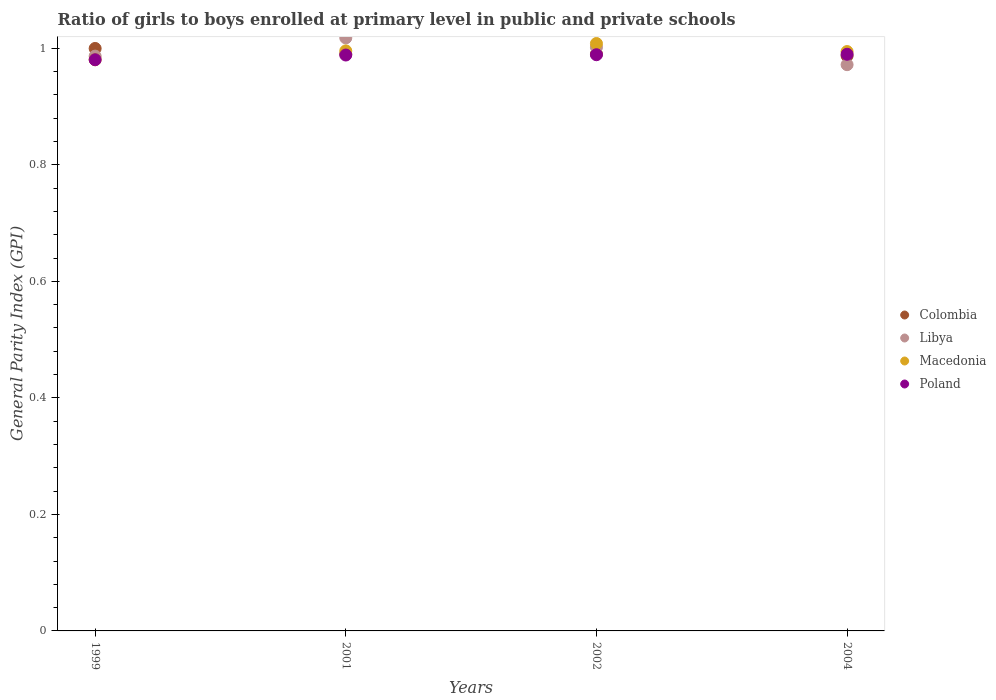What is the general parity index in Macedonia in 1999?
Ensure brevity in your answer.  0.98. Across all years, what is the maximum general parity index in Colombia?
Give a very brief answer. 1. Across all years, what is the minimum general parity index in Macedonia?
Offer a very short reply. 0.98. What is the total general parity index in Macedonia in the graph?
Keep it short and to the point. 3.98. What is the difference between the general parity index in Macedonia in 1999 and that in 2004?
Provide a succinct answer. -0.01. What is the difference between the general parity index in Libya in 1999 and the general parity index in Poland in 2001?
Your answer should be compact. -0. What is the average general parity index in Colombia per year?
Your answer should be compact. 0.99. In the year 1999, what is the difference between the general parity index in Macedonia and general parity index in Colombia?
Your response must be concise. -0.02. What is the ratio of the general parity index in Poland in 1999 to that in 2001?
Keep it short and to the point. 0.99. Is the general parity index in Colombia in 1999 less than that in 2002?
Give a very brief answer. No. Is the difference between the general parity index in Macedonia in 1999 and 2002 greater than the difference between the general parity index in Colombia in 1999 and 2002?
Provide a short and direct response. No. What is the difference between the highest and the second highest general parity index in Macedonia?
Your answer should be very brief. 0.01. What is the difference between the highest and the lowest general parity index in Poland?
Offer a terse response. 0.01. In how many years, is the general parity index in Libya greater than the average general parity index in Libya taken over all years?
Give a very brief answer. 2. Is it the case that in every year, the sum of the general parity index in Libya and general parity index in Colombia  is greater than the sum of general parity index in Macedonia and general parity index in Poland?
Provide a short and direct response. No. Is the general parity index in Poland strictly greater than the general parity index in Colombia over the years?
Give a very brief answer. No. How many years are there in the graph?
Your answer should be very brief. 4. Does the graph contain any zero values?
Offer a very short reply. No. Does the graph contain grids?
Offer a terse response. No. What is the title of the graph?
Your answer should be very brief. Ratio of girls to boys enrolled at primary level in public and private schools. Does "Europe(all income levels)" appear as one of the legend labels in the graph?
Provide a short and direct response. No. What is the label or title of the Y-axis?
Keep it short and to the point. General Parity Index (GPI). What is the General Parity Index (GPI) in Colombia in 1999?
Your answer should be very brief. 1. What is the General Parity Index (GPI) of Libya in 1999?
Provide a short and direct response. 0.99. What is the General Parity Index (GPI) of Macedonia in 1999?
Provide a short and direct response. 0.98. What is the General Parity Index (GPI) of Poland in 1999?
Provide a short and direct response. 0.98. What is the General Parity Index (GPI) of Colombia in 2001?
Your answer should be compact. 0.99. What is the General Parity Index (GPI) of Libya in 2001?
Keep it short and to the point. 1.02. What is the General Parity Index (GPI) of Macedonia in 2001?
Offer a very short reply. 1. What is the General Parity Index (GPI) of Poland in 2001?
Offer a very short reply. 0.99. What is the General Parity Index (GPI) in Colombia in 2002?
Ensure brevity in your answer.  0.99. What is the General Parity Index (GPI) in Libya in 2002?
Provide a succinct answer. 1. What is the General Parity Index (GPI) in Macedonia in 2002?
Offer a terse response. 1.01. What is the General Parity Index (GPI) in Poland in 2002?
Make the answer very short. 0.99. What is the General Parity Index (GPI) of Colombia in 2004?
Ensure brevity in your answer.  0.99. What is the General Parity Index (GPI) of Libya in 2004?
Your answer should be compact. 0.97. What is the General Parity Index (GPI) in Macedonia in 2004?
Give a very brief answer. 0.99. What is the General Parity Index (GPI) in Poland in 2004?
Your answer should be compact. 0.99. Across all years, what is the maximum General Parity Index (GPI) of Colombia?
Your answer should be very brief. 1. Across all years, what is the maximum General Parity Index (GPI) in Libya?
Provide a short and direct response. 1.02. Across all years, what is the maximum General Parity Index (GPI) in Macedonia?
Provide a succinct answer. 1.01. Across all years, what is the maximum General Parity Index (GPI) in Poland?
Make the answer very short. 0.99. Across all years, what is the minimum General Parity Index (GPI) of Colombia?
Make the answer very short. 0.99. Across all years, what is the minimum General Parity Index (GPI) of Libya?
Ensure brevity in your answer.  0.97. Across all years, what is the minimum General Parity Index (GPI) of Macedonia?
Your response must be concise. 0.98. Across all years, what is the minimum General Parity Index (GPI) of Poland?
Offer a very short reply. 0.98. What is the total General Parity Index (GPI) of Colombia in the graph?
Give a very brief answer. 3.97. What is the total General Parity Index (GPI) of Libya in the graph?
Provide a short and direct response. 3.98. What is the total General Parity Index (GPI) in Macedonia in the graph?
Your answer should be very brief. 3.98. What is the total General Parity Index (GPI) of Poland in the graph?
Offer a terse response. 3.95. What is the difference between the General Parity Index (GPI) of Colombia in 1999 and that in 2001?
Ensure brevity in your answer.  0.01. What is the difference between the General Parity Index (GPI) in Libya in 1999 and that in 2001?
Offer a terse response. -0.03. What is the difference between the General Parity Index (GPI) of Macedonia in 1999 and that in 2001?
Offer a terse response. -0.02. What is the difference between the General Parity Index (GPI) in Poland in 1999 and that in 2001?
Your response must be concise. -0.01. What is the difference between the General Parity Index (GPI) of Colombia in 1999 and that in 2002?
Your answer should be compact. 0.01. What is the difference between the General Parity Index (GPI) in Libya in 1999 and that in 2002?
Provide a succinct answer. -0.02. What is the difference between the General Parity Index (GPI) in Macedonia in 1999 and that in 2002?
Provide a succinct answer. -0.03. What is the difference between the General Parity Index (GPI) of Poland in 1999 and that in 2002?
Your response must be concise. -0.01. What is the difference between the General Parity Index (GPI) of Colombia in 1999 and that in 2004?
Provide a succinct answer. 0.01. What is the difference between the General Parity Index (GPI) in Libya in 1999 and that in 2004?
Offer a very short reply. 0.01. What is the difference between the General Parity Index (GPI) in Macedonia in 1999 and that in 2004?
Give a very brief answer. -0.01. What is the difference between the General Parity Index (GPI) of Poland in 1999 and that in 2004?
Your answer should be very brief. -0.01. What is the difference between the General Parity Index (GPI) of Colombia in 2001 and that in 2002?
Provide a short and direct response. -0. What is the difference between the General Parity Index (GPI) of Libya in 2001 and that in 2002?
Ensure brevity in your answer.  0.02. What is the difference between the General Parity Index (GPI) of Macedonia in 2001 and that in 2002?
Your answer should be compact. -0.01. What is the difference between the General Parity Index (GPI) in Poland in 2001 and that in 2002?
Keep it short and to the point. -0. What is the difference between the General Parity Index (GPI) of Colombia in 2001 and that in 2004?
Give a very brief answer. 0. What is the difference between the General Parity Index (GPI) in Libya in 2001 and that in 2004?
Keep it short and to the point. 0.05. What is the difference between the General Parity Index (GPI) in Macedonia in 2001 and that in 2004?
Make the answer very short. 0. What is the difference between the General Parity Index (GPI) in Poland in 2001 and that in 2004?
Provide a succinct answer. -0. What is the difference between the General Parity Index (GPI) of Colombia in 2002 and that in 2004?
Provide a short and direct response. 0. What is the difference between the General Parity Index (GPI) in Libya in 2002 and that in 2004?
Provide a succinct answer. 0.03. What is the difference between the General Parity Index (GPI) in Macedonia in 2002 and that in 2004?
Make the answer very short. 0.01. What is the difference between the General Parity Index (GPI) in Poland in 2002 and that in 2004?
Your response must be concise. -0. What is the difference between the General Parity Index (GPI) of Colombia in 1999 and the General Parity Index (GPI) of Libya in 2001?
Offer a terse response. -0.02. What is the difference between the General Parity Index (GPI) of Colombia in 1999 and the General Parity Index (GPI) of Macedonia in 2001?
Keep it short and to the point. 0. What is the difference between the General Parity Index (GPI) of Colombia in 1999 and the General Parity Index (GPI) of Poland in 2001?
Your response must be concise. 0.01. What is the difference between the General Parity Index (GPI) in Libya in 1999 and the General Parity Index (GPI) in Macedonia in 2001?
Your response must be concise. -0.01. What is the difference between the General Parity Index (GPI) of Libya in 1999 and the General Parity Index (GPI) of Poland in 2001?
Give a very brief answer. -0. What is the difference between the General Parity Index (GPI) of Macedonia in 1999 and the General Parity Index (GPI) of Poland in 2001?
Offer a very short reply. -0.01. What is the difference between the General Parity Index (GPI) of Colombia in 1999 and the General Parity Index (GPI) of Libya in 2002?
Offer a terse response. -0. What is the difference between the General Parity Index (GPI) of Colombia in 1999 and the General Parity Index (GPI) of Macedonia in 2002?
Give a very brief answer. -0.01. What is the difference between the General Parity Index (GPI) in Colombia in 1999 and the General Parity Index (GPI) in Poland in 2002?
Your answer should be very brief. 0.01. What is the difference between the General Parity Index (GPI) in Libya in 1999 and the General Parity Index (GPI) in Macedonia in 2002?
Your answer should be very brief. -0.02. What is the difference between the General Parity Index (GPI) of Libya in 1999 and the General Parity Index (GPI) of Poland in 2002?
Provide a succinct answer. -0. What is the difference between the General Parity Index (GPI) in Macedonia in 1999 and the General Parity Index (GPI) in Poland in 2002?
Your response must be concise. -0.01. What is the difference between the General Parity Index (GPI) in Colombia in 1999 and the General Parity Index (GPI) in Libya in 2004?
Ensure brevity in your answer.  0.03. What is the difference between the General Parity Index (GPI) in Colombia in 1999 and the General Parity Index (GPI) in Macedonia in 2004?
Your answer should be compact. 0.01. What is the difference between the General Parity Index (GPI) of Colombia in 1999 and the General Parity Index (GPI) of Poland in 2004?
Provide a short and direct response. 0.01. What is the difference between the General Parity Index (GPI) in Libya in 1999 and the General Parity Index (GPI) in Macedonia in 2004?
Offer a terse response. -0.01. What is the difference between the General Parity Index (GPI) of Libya in 1999 and the General Parity Index (GPI) of Poland in 2004?
Offer a terse response. -0. What is the difference between the General Parity Index (GPI) in Macedonia in 1999 and the General Parity Index (GPI) in Poland in 2004?
Offer a terse response. -0.01. What is the difference between the General Parity Index (GPI) of Colombia in 2001 and the General Parity Index (GPI) of Libya in 2002?
Make the answer very short. -0.01. What is the difference between the General Parity Index (GPI) of Colombia in 2001 and the General Parity Index (GPI) of Macedonia in 2002?
Provide a succinct answer. -0.02. What is the difference between the General Parity Index (GPI) in Colombia in 2001 and the General Parity Index (GPI) in Poland in 2002?
Ensure brevity in your answer.  0. What is the difference between the General Parity Index (GPI) of Libya in 2001 and the General Parity Index (GPI) of Macedonia in 2002?
Provide a succinct answer. 0.01. What is the difference between the General Parity Index (GPI) in Libya in 2001 and the General Parity Index (GPI) in Poland in 2002?
Offer a very short reply. 0.03. What is the difference between the General Parity Index (GPI) of Macedonia in 2001 and the General Parity Index (GPI) of Poland in 2002?
Offer a terse response. 0.01. What is the difference between the General Parity Index (GPI) of Colombia in 2001 and the General Parity Index (GPI) of Libya in 2004?
Offer a terse response. 0.02. What is the difference between the General Parity Index (GPI) of Colombia in 2001 and the General Parity Index (GPI) of Macedonia in 2004?
Provide a succinct answer. -0. What is the difference between the General Parity Index (GPI) of Colombia in 2001 and the General Parity Index (GPI) of Poland in 2004?
Your response must be concise. 0. What is the difference between the General Parity Index (GPI) in Libya in 2001 and the General Parity Index (GPI) in Macedonia in 2004?
Offer a very short reply. 0.02. What is the difference between the General Parity Index (GPI) of Libya in 2001 and the General Parity Index (GPI) of Poland in 2004?
Ensure brevity in your answer.  0.03. What is the difference between the General Parity Index (GPI) of Macedonia in 2001 and the General Parity Index (GPI) of Poland in 2004?
Make the answer very short. 0.01. What is the difference between the General Parity Index (GPI) in Colombia in 2002 and the General Parity Index (GPI) in Libya in 2004?
Your answer should be compact. 0.02. What is the difference between the General Parity Index (GPI) of Colombia in 2002 and the General Parity Index (GPI) of Macedonia in 2004?
Your response must be concise. -0. What is the difference between the General Parity Index (GPI) of Colombia in 2002 and the General Parity Index (GPI) of Poland in 2004?
Ensure brevity in your answer.  0. What is the difference between the General Parity Index (GPI) in Libya in 2002 and the General Parity Index (GPI) in Macedonia in 2004?
Give a very brief answer. 0.01. What is the difference between the General Parity Index (GPI) of Libya in 2002 and the General Parity Index (GPI) of Poland in 2004?
Your answer should be compact. 0.01. What is the difference between the General Parity Index (GPI) in Macedonia in 2002 and the General Parity Index (GPI) in Poland in 2004?
Keep it short and to the point. 0.02. What is the average General Parity Index (GPI) in Colombia per year?
Make the answer very short. 0.99. What is the average General Parity Index (GPI) in Poland per year?
Your answer should be compact. 0.99. In the year 1999, what is the difference between the General Parity Index (GPI) in Colombia and General Parity Index (GPI) in Libya?
Offer a terse response. 0.01. In the year 1999, what is the difference between the General Parity Index (GPI) of Colombia and General Parity Index (GPI) of Macedonia?
Ensure brevity in your answer.  0.02. In the year 1999, what is the difference between the General Parity Index (GPI) of Colombia and General Parity Index (GPI) of Poland?
Your response must be concise. 0.02. In the year 1999, what is the difference between the General Parity Index (GPI) in Libya and General Parity Index (GPI) in Macedonia?
Keep it short and to the point. 0.01. In the year 1999, what is the difference between the General Parity Index (GPI) in Libya and General Parity Index (GPI) in Poland?
Offer a terse response. 0.01. In the year 1999, what is the difference between the General Parity Index (GPI) in Macedonia and General Parity Index (GPI) in Poland?
Offer a very short reply. -0. In the year 2001, what is the difference between the General Parity Index (GPI) in Colombia and General Parity Index (GPI) in Libya?
Offer a terse response. -0.03. In the year 2001, what is the difference between the General Parity Index (GPI) of Colombia and General Parity Index (GPI) of Macedonia?
Offer a very short reply. -0.01. In the year 2001, what is the difference between the General Parity Index (GPI) of Colombia and General Parity Index (GPI) of Poland?
Your response must be concise. 0. In the year 2001, what is the difference between the General Parity Index (GPI) of Libya and General Parity Index (GPI) of Macedonia?
Make the answer very short. 0.02. In the year 2001, what is the difference between the General Parity Index (GPI) in Libya and General Parity Index (GPI) in Poland?
Your answer should be very brief. 0.03. In the year 2001, what is the difference between the General Parity Index (GPI) of Macedonia and General Parity Index (GPI) of Poland?
Your response must be concise. 0.01. In the year 2002, what is the difference between the General Parity Index (GPI) of Colombia and General Parity Index (GPI) of Libya?
Offer a very short reply. -0.01. In the year 2002, what is the difference between the General Parity Index (GPI) of Colombia and General Parity Index (GPI) of Macedonia?
Your response must be concise. -0.02. In the year 2002, what is the difference between the General Parity Index (GPI) in Colombia and General Parity Index (GPI) in Poland?
Provide a succinct answer. 0. In the year 2002, what is the difference between the General Parity Index (GPI) in Libya and General Parity Index (GPI) in Macedonia?
Provide a short and direct response. -0.01. In the year 2002, what is the difference between the General Parity Index (GPI) in Libya and General Parity Index (GPI) in Poland?
Provide a short and direct response. 0.01. In the year 2002, what is the difference between the General Parity Index (GPI) of Macedonia and General Parity Index (GPI) of Poland?
Your response must be concise. 0.02. In the year 2004, what is the difference between the General Parity Index (GPI) of Colombia and General Parity Index (GPI) of Libya?
Make the answer very short. 0.02. In the year 2004, what is the difference between the General Parity Index (GPI) of Colombia and General Parity Index (GPI) of Macedonia?
Give a very brief answer. -0.01. In the year 2004, what is the difference between the General Parity Index (GPI) in Colombia and General Parity Index (GPI) in Poland?
Your answer should be very brief. -0. In the year 2004, what is the difference between the General Parity Index (GPI) of Libya and General Parity Index (GPI) of Macedonia?
Your response must be concise. -0.02. In the year 2004, what is the difference between the General Parity Index (GPI) of Libya and General Parity Index (GPI) of Poland?
Offer a very short reply. -0.02. In the year 2004, what is the difference between the General Parity Index (GPI) of Macedonia and General Parity Index (GPI) of Poland?
Offer a very short reply. 0. What is the ratio of the General Parity Index (GPI) of Colombia in 1999 to that in 2001?
Ensure brevity in your answer.  1.01. What is the ratio of the General Parity Index (GPI) in Libya in 1999 to that in 2001?
Provide a short and direct response. 0.97. What is the ratio of the General Parity Index (GPI) of Macedonia in 1999 to that in 2001?
Provide a succinct answer. 0.98. What is the ratio of the General Parity Index (GPI) in Poland in 1999 to that in 2001?
Provide a short and direct response. 0.99. What is the ratio of the General Parity Index (GPI) in Colombia in 1999 to that in 2002?
Ensure brevity in your answer.  1.01. What is the ratio of the General Parity Index (GPI) of Macedonia in 1999 to that in 2002?
Give a very brief answer. 0.97. What is the ratio of the General Parity Index (GPI) of Poland in 1999 to that in 2002?
Your response must be concise. 0.99. What is the ratio of the General Parity Index (GPI) in Colombia in 1999 to that in 2004?
Offer a terse response. 1.01. What is the ratio of the General Parity Index (GPI) of Libya in 1999 to that in 2004?
Your response must be concise. 1.02. What is the ratio of the General Parity Index (GPI) of Macedonia in 1999 to that in 2004?
Offer a very short reply. 0.99. What is the ratio of the General Parity Index (GPI) in Libya in 2001 to that in 2002?
Offer a very short reply. 1.02. What is the ratio of the General Parity Index (GPI) in Macedonia in 2001 to that in 2002?
Make the answer very short. 0.99. What is the ratio of the General Parity Index (GPI) in Libya in 2001 to that in 2004?
Give a very brief answer. 1.05. What is the ratio of the General Parity Index (GPI) in Macedonia in 2001 to that in 2004?
Provide a short and direct response. 1. What is the ratio of the General Parity Index (GPI) of Poland in 2001 to that in 2004?
Ensure brevity in your answer.  1. What is the ratio of the General Parity Index (GPI) in Libya in 2002 to that in 2004?
Your answer should be very brief. 1.03. What is the ratio of the General Parity Index (GPI) of Macedonia in 2002 to that in 2004?
Offer a terse response. 1.01. What is the difference between the highest and the second highest General Parity Index (GPI) of Colombia?
Your answer should be compact. 0.01. What is the difference between the highest and the second highest General Parity Index (GPI) in Libya?
Your answer should be very brief. 0.02. What is the difference between the highest and the second highest General Parity Index (GPI) of Macedonia?
Provide a short and direct response. 0.01. What is the difference between the highest and the second highest General Parity Index (GPI) of Poland?
Your answer should be compact. 0. What is the difference between the highest and the lowest General Parity Index (GPI) in Colombia?
Provide a short and direct response. 0.01. What is the difference between the highest and the lowest General Parity Index (GPI) of Libya?
Provide a succinct answer. 0.05. What is the difference between the highest and the lowest General Parity Index (GPI) of Macedonia?
Provide a short and direct response. 0.03. What is the difference between the highest and the lowest General Parity Index (GPI) of Poland?
Keep it short and to the point. 0.01. 